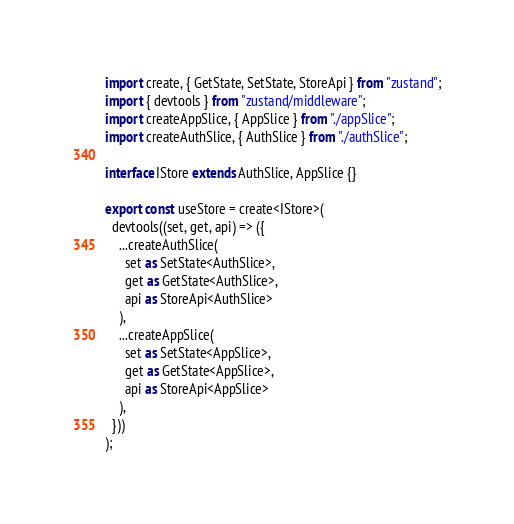<code> <loc_0><loc_0><loc_500><loc_500><_TypeScript_>import create, { GetState, SetState, StoreApi } from "zustand";
import { devtools } from "zustand/middleware";
import createAppSlice, { AppSlice } from "./appSlice";
import createAuthSlice, { AuthSlice } from "./authSlice";

interface IStore extends AuthSlice, AppSlice {}

export const useStore = create<IStore>(
  devtools((set, get, api) => ({
    ...createAuthSlice(
      set as SetState<AuthSlice>,
      get as GetState<AuthSlice>,
      api as StoreApi<AuthSlice>
    ),
    ...createAppSlice(
      set as SetState<AppSlice>,
      get as GetState<AppSlice>,
      api as StoreApi<AppSlice>
    ),
  }))
);
</code> 